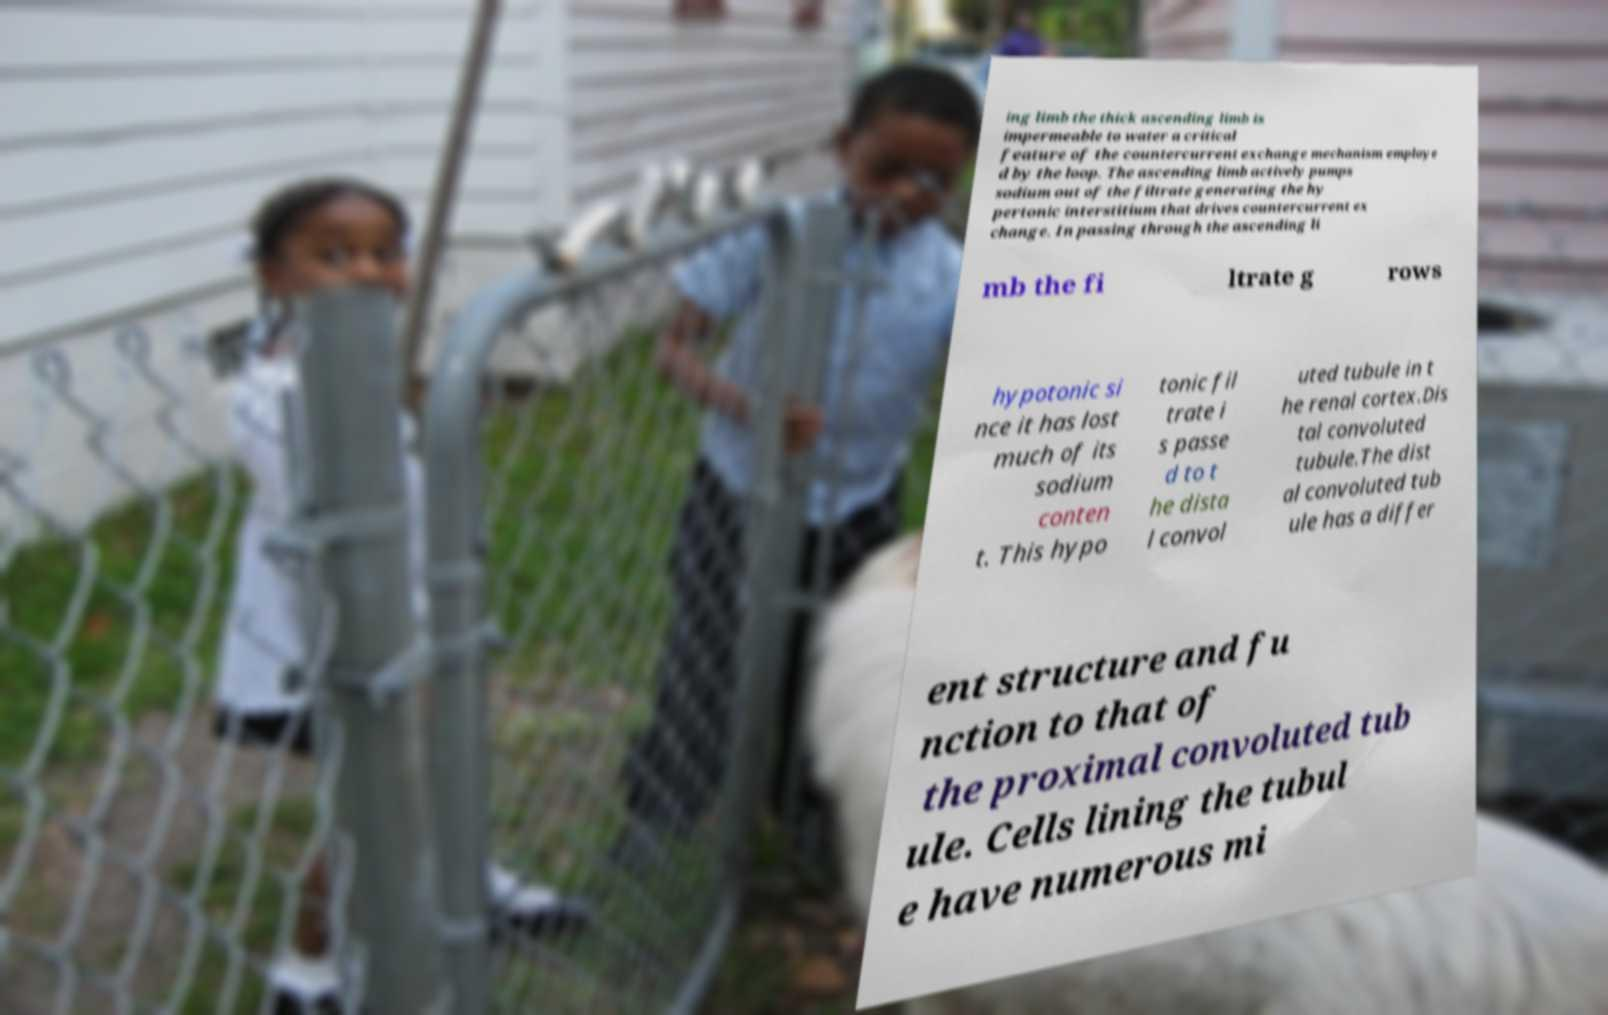Could you assist in decoding the text presented in this image and type it out clearly? ing limb the thick ascending limb is impermeable to water a critical feature of the countercurrent exchange mechanism employe d by the loop. The ascending limb actively pumps sodium out of the filtrate generating the hy pertonic interstitium that drives countercurrent ex change. In passing through the ascending li mb the fi ltrate g rows hypotonic si nce it has lost much of its sodium conten t. This hypo tonic fil trate i s passe d to t he dista l convol uted tubule in t he renal cortex.Dis tal convoluted tubule.The dist al convoluted tub ule has a differ ent structure and fu nction to that of the proximal convoluted tub ule. Cells lining the tubul e have numerous mi 